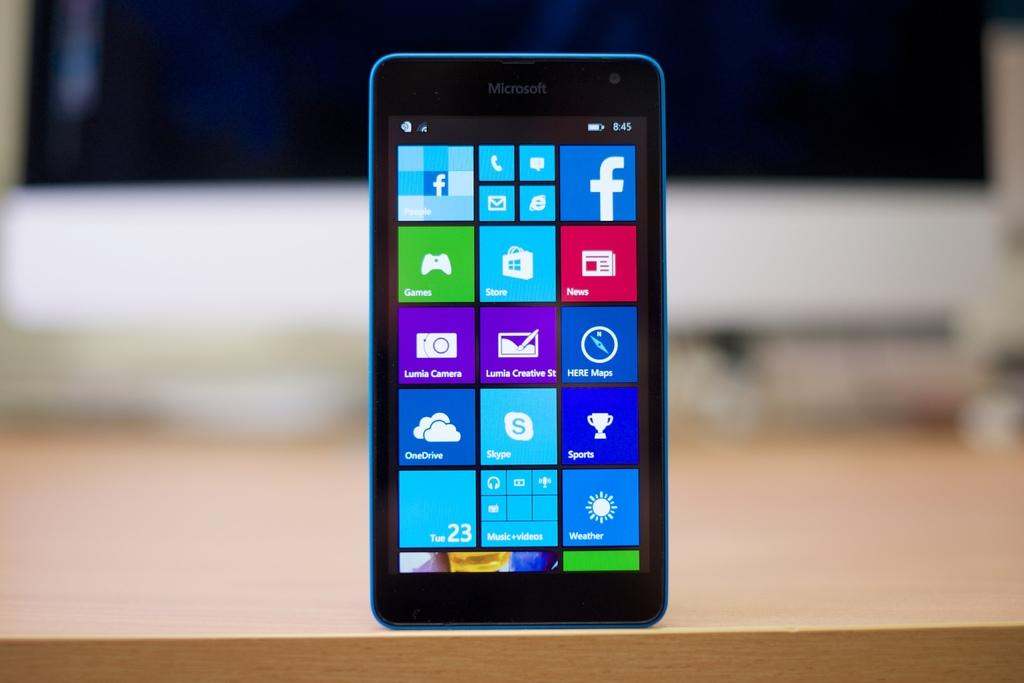<image>
Render a clear and concise summary of the photo. The screen of a microsoft branded windows phone with an icon for facebook on the top right side. 